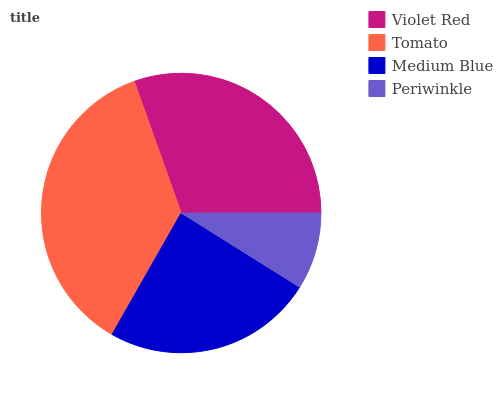Is Periwinkle the minimum?
Answer yes or no. Yes. Is Tomato the maximum?
Answer yes or no. Yes. Is Medium Blue the minimum?
Answer yes or no. No. Is Medium Blue the maximum?
Answer yes or no. No. Is Tomato greater than Medium Blue?
Answer yes or no. Yes. Is Medium Blue less than Tomato?
Answer yes or no. Yes. Is Medium Blue greater than Tomato?
Answer yes or no. No. Is Tomato less than Medium Blue?
Answer yes or no. No. Is Violet Red the high median?
Answer yes or no. Yes. Is Medium Blue the low median?
Answer yes or no. Yes. Is Tomato the high median?
Answer yes or no. No. Is Violet Red the low median?
Answer yes or no. No. 